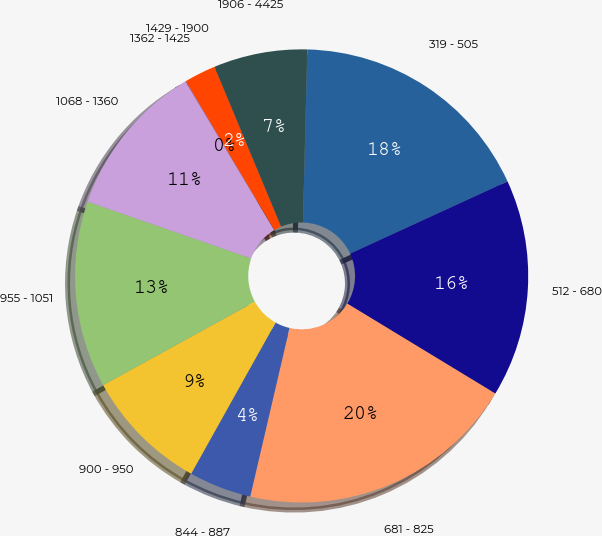<chart> <loc_0><loc_0><loc_500><loc_500><pie_chart><fcel>319 - 505<fcel>512 - 680<fcel>681 - 825<fcel>844 - 887<fcel>900 - 950<fcel>955 - 1051<fcel>1068 - 1360<fcel>1362 - 1425<fcel>1429 - 1900<fcel>1906 - 4425<nl><fcel>17.75%<fcel>15.54%<fcel>19.96%<fcel>4.46%<fcel>8.89%<fcel>13.32%<fcel>11.11%<fcel>0.04%<fcel>2.25%<fcel>6.68%<nl></chart> 